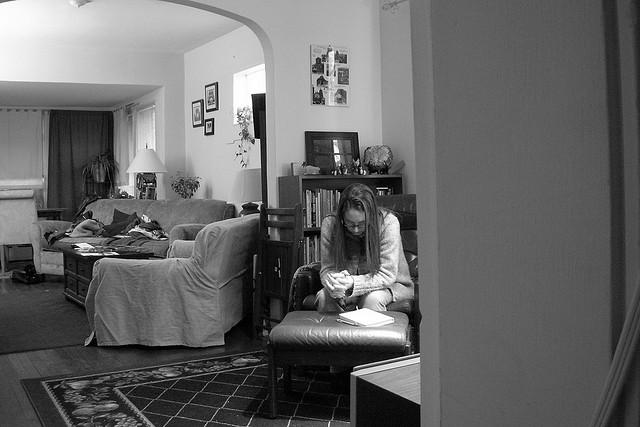What room is this?
Be succinct. Living room. What color is the bookshelf?
Short answer required. Black. Is this a color photo?
Give a very brief answer. No. What is the woman doing?
Short answer required. Reading. Do someone sleeping on the couch?
Short answer required. No. Is it day or night?
Be succinct. Day. 